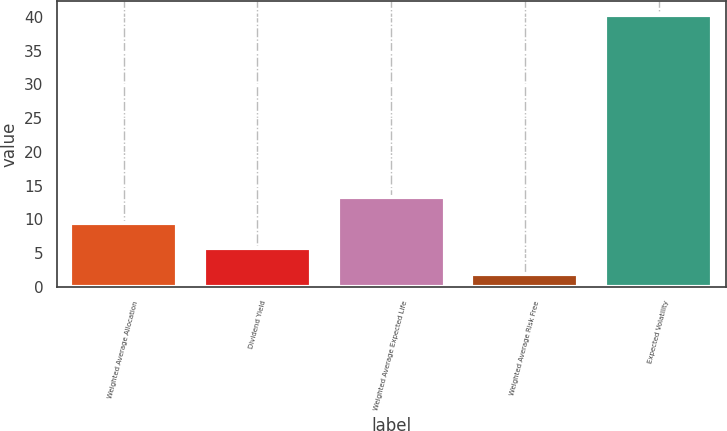<chart> <loc_0><loc_0><loc_500><loc_500><bar_chart><fcel>Weighted Average Allocation<fcel>Dividend Yield<fcel>Weighted Average Expected Life<fcel>Weighted Average Risk Free<fcel>Expected Volatility<nl><fcel>9.52<fcel>5.68<fcel>13.36<fcel>1.84<fcel>40.28<nl></chart> 